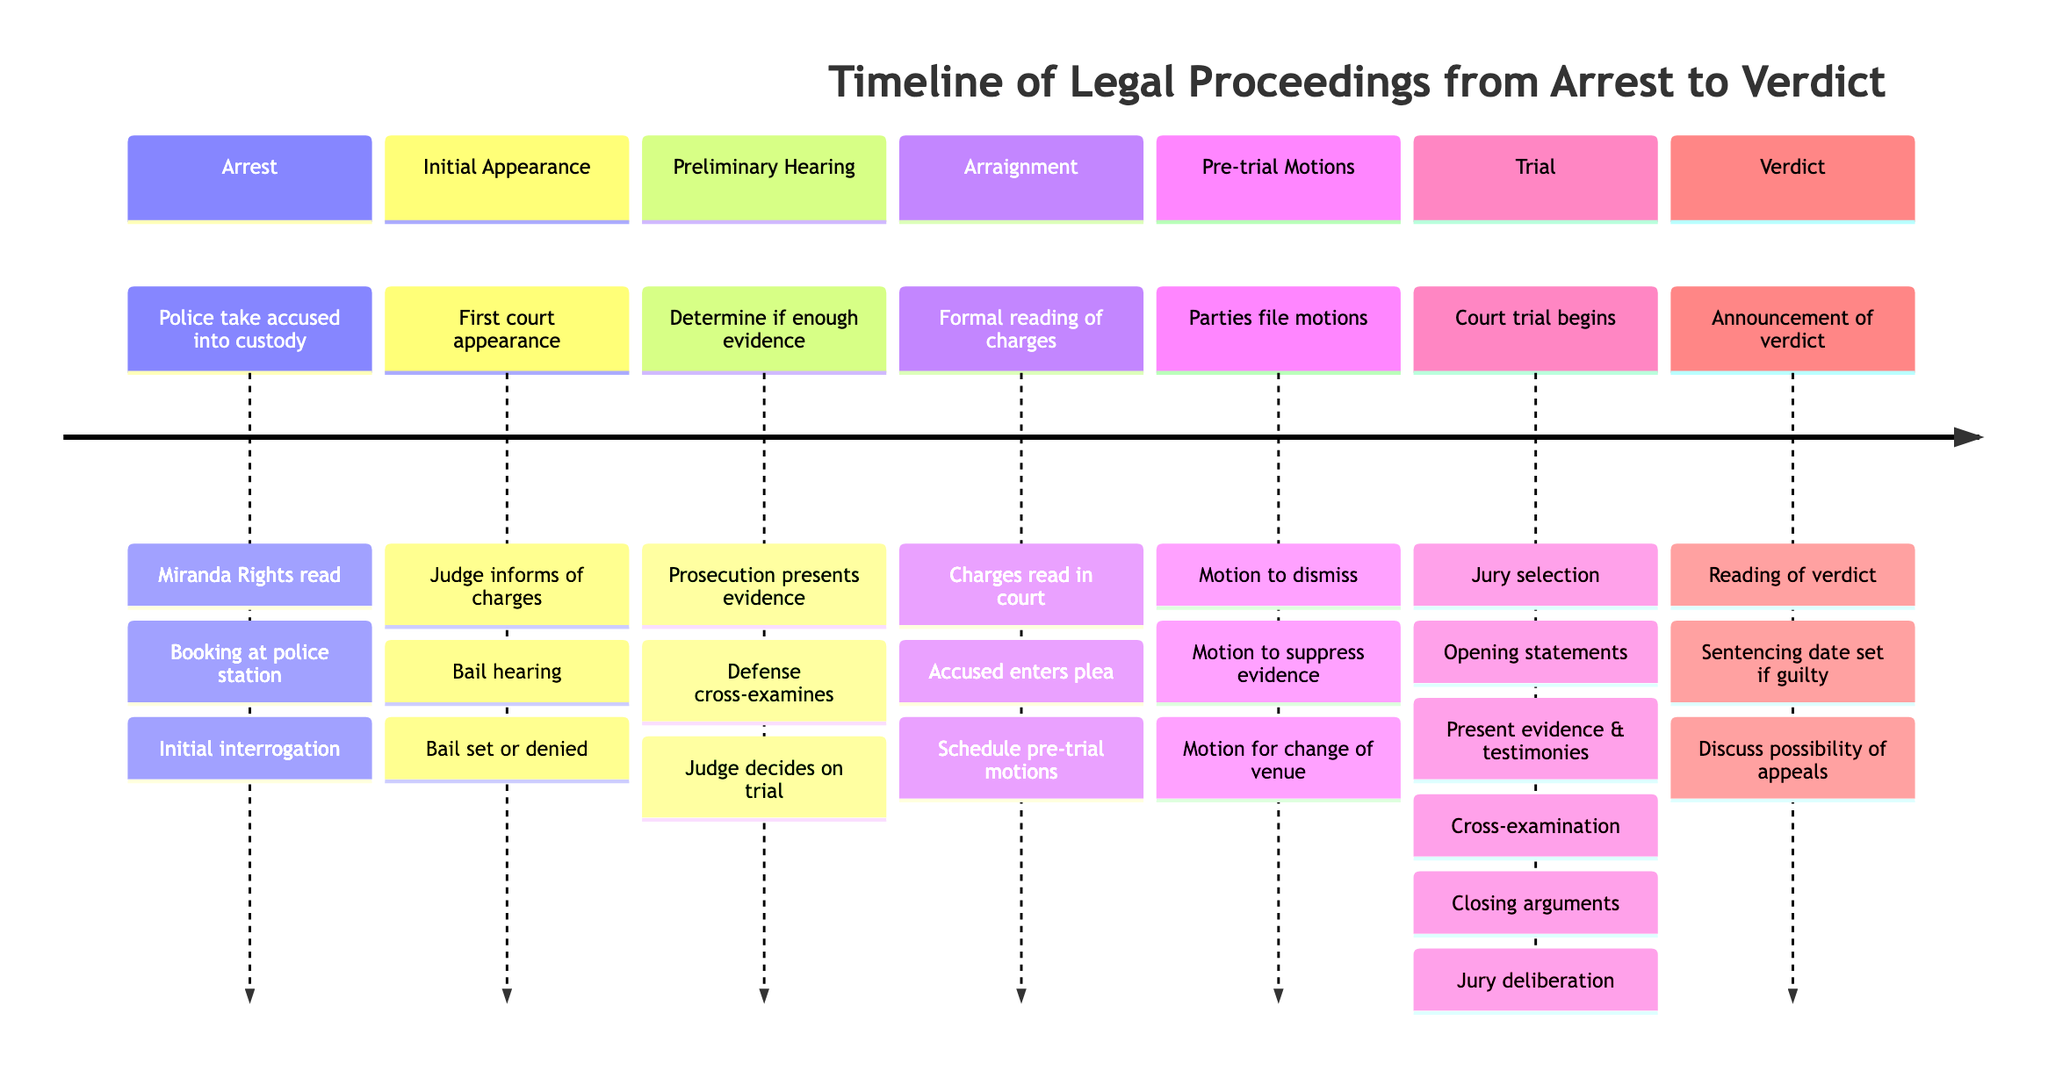What is the first stage in the legal proceedings? The first stage listed in the timeline is "Arrest," which is stated at the beginning of the diagram.
Answer: Arrest How many key events occur during the Trial stage? In the Trial stage, there are six key events listed: Jury selection, Opening statements, Presentation of evidence and witness testimonies, Cross-examination by defense, Closing arguments, and Jury deliberation. Counting these, we find a total of 6 key events.
Answer: 6 What occurs immediately after the Arraignment stage? After the Arraignment stage, the next stage listed is "Pre-trial Motions." This is based on the sequencing of events in the timeline.
Answer: Pre-trial Motions What type of motions can be filed during the Pre-trial Motions stage? During the Pre-trial Motions stage, three types of motions can be filed: Motion to dismiss, Motion to suppress evidence, and Motion for change of venue. All of these are explicitly stated in the timeline.
Answer: Motion to dismiss, Motion to suppress evidence, Motion for change of venue What is the final stage of the legal proceedings timeline? The final stage in the timeline is "Verdict," and this appears last, indicating it is the concluding phase of the legal process described.
Answer: Verdict What happens during the Initial Appearance stage? During the Initial Appearance stage, three key events occur: Judge informs accused of charges, Bail hearing, and Bail set or denied. These events are specified directly under this stage in the timeline.
Answer: Judge informs accused of charges, Bail hearing, Bail set or denied How many stages are there in the Timeline of Legal Proceedings? There are a total of seven stages identified in the timeline: Arrest, Initial Appearance, Preliminary Hearing, Arraignment, Pre-trial Motions, Trial, and Verdict. By counting these stages, we arrive at the total number.
Answer: 7 Which stage involves both parties presenting evidence? The stage where both parties present evidence occurs is the Trial stage, as explicitly stated in the timeline. This includes the prosecution presenting evidence and the defense cross-examining witnesses.
Answer: Trial What is scheduled during the Arraignment stage? During the Arraignment stage, the scheduling of pre-trial motions and the trial date is noted as a key event, indicating these are planned during this stage.
Answer: Scheduling of pre-trial motions and trial date 